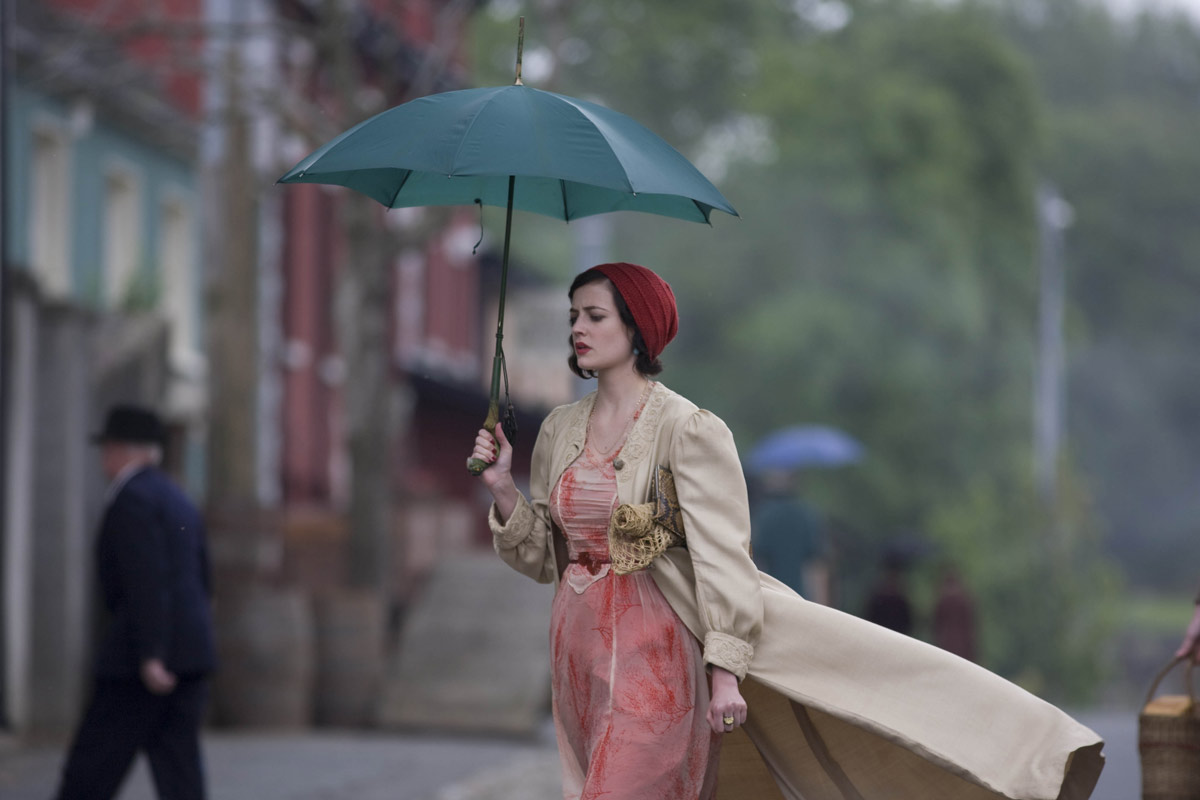What does the setting tell us about the era in which this scene is set? The cobblestone streets, the attire of the characters, and the presence of a horse-drawn carriage all point to a setting in the late 19th to early 20th century, reflecting a time before modern vehicles, highlighting an era that valued distinct fashion and slower paced life. How does the color palette used in the image influence the mood? The subdued and earthy color palette, with soft shades of peach, beige, and muted greens, suggests a nostalgic and possibly melancholic mood, evoking a sense of the past and perhaps underscoring the reflective state of the character. 